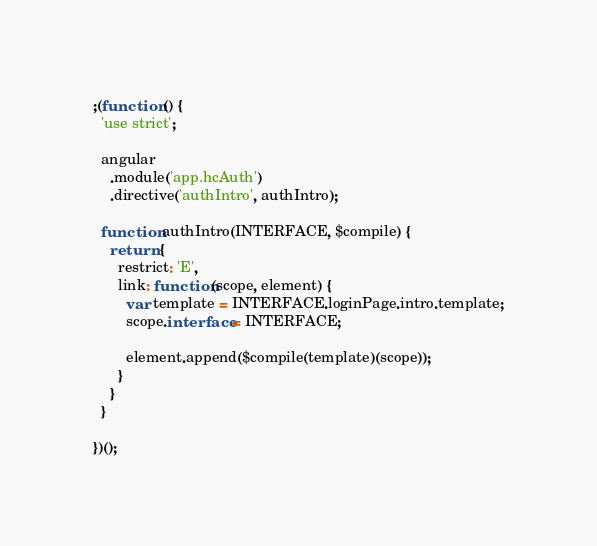<code> <loc_0><loc_0><loc_500><loc_500><_JavaScript_>;(function () {
  'use strict';

  angular
    .module('app.hcAuth')
    .directive('authIntro', authIntro);

  function authIntro(INTERFACE, $compile) {
    return {
      restrict: 'E',
      link: function(scope, element) {
        var template = INTERFACE.loginPage.intro.template;
        scope.interface = INTERFACE;

        element.append($compile(template)(scope));
      }
    }
  }

})();</code> 